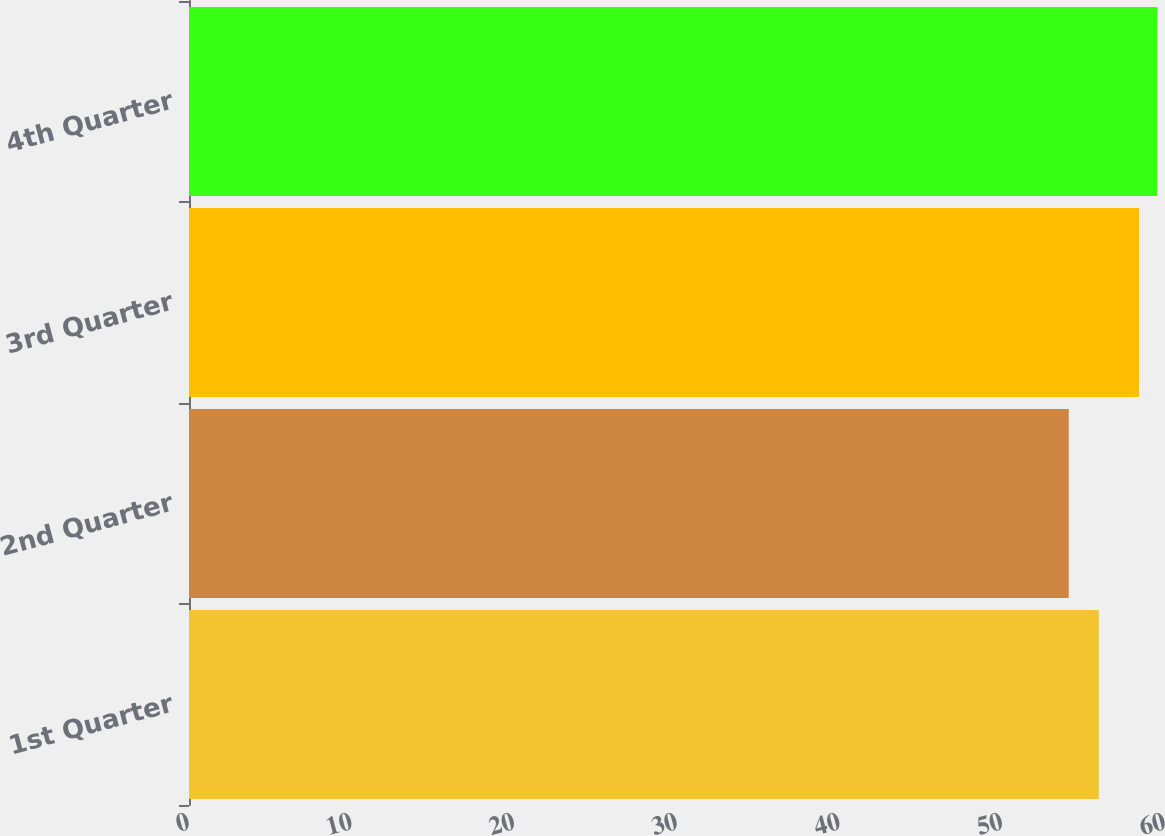Convert chart to OTSL. <chart><loc_0><loc_0><loc_500><loc_500><bar_chart><fcel>1st Quarter<fcel>2nd Quarter<fcel>3rd Quarter<fcel>4th Quarter<nl><fcel>55.93<fcel>54.08<fcel>58.4<fcel>59.53<nl></chart> 